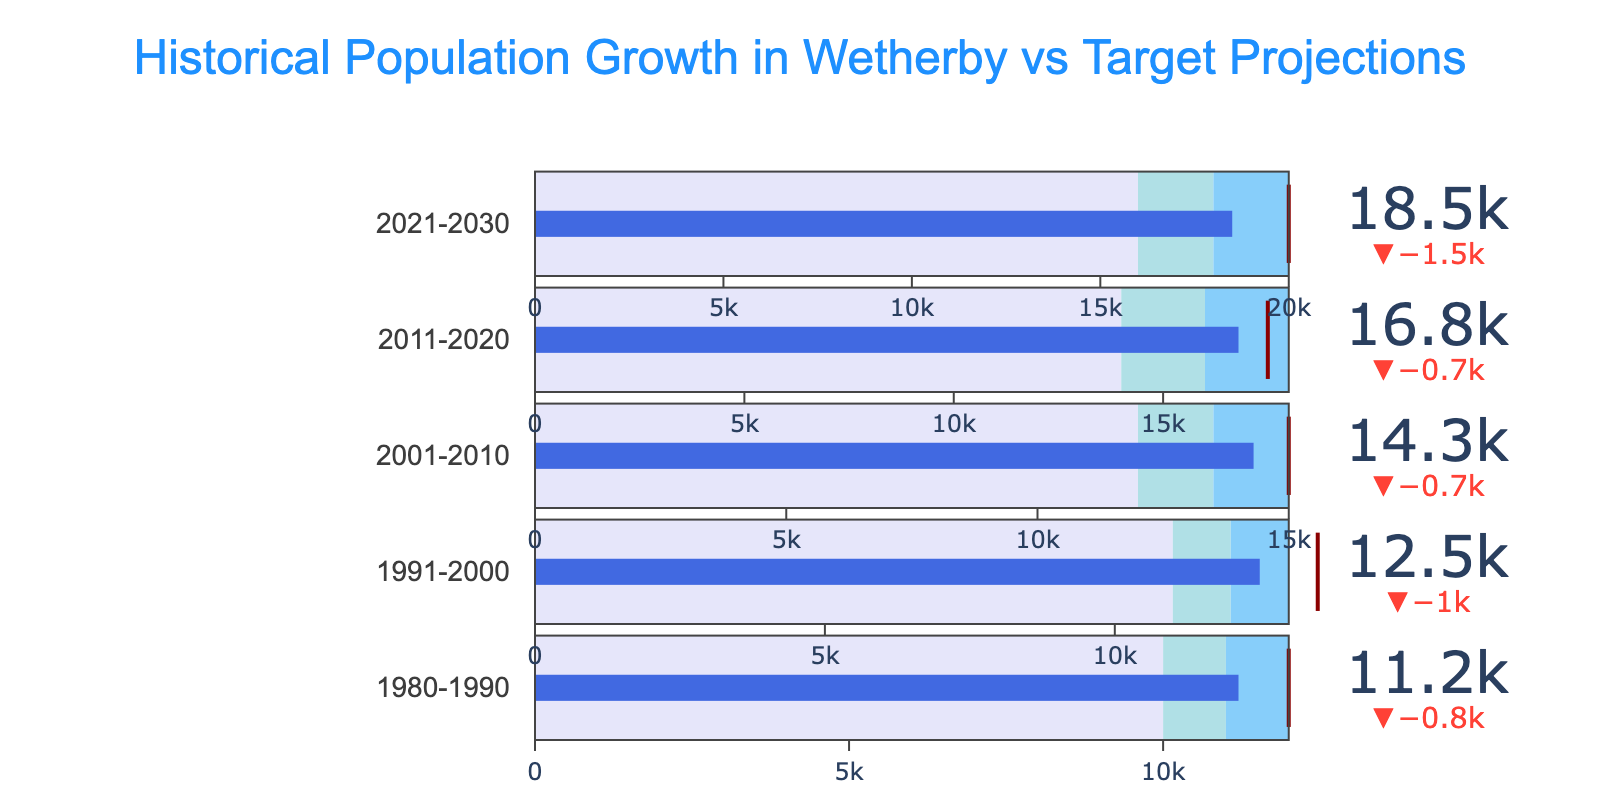What's the title of the figure? The title is prominently displayed at the top of the figure in a larger font size.
Answer: Historical Population Growth in Wetherby vs Target Projections In which decade did Wetherby's actual population first surpass the target projection? By analyzing the bullet chart data, we observe that the actual population surpassed the target in the decade 2011-2020 where the actual value (16800) exceeds the target (17500).
Answer: 2011-2020 How many decades are represented in the figure? The figure has sections corresponding to each decade, counting them we find five distinct categories.
Answer: Five What was the actual population growth for Wetherby in 2001-2010? Referring to the section labeled 2001-2010 in the figure, the actual population value is given explicitly.
Answer: 14300 How does the actual population in 2021-2030 compare to the target projection? Comparing the actual population (18500) with the target projection (20000) for this period, it is observed that the actual population is slightly below the target.
Answer: Below target During which decade did Wetherby's population have the smallest difference from its target? To find this, subtract the actual population from the target for each decade and identify the one with the smallest difference. The smallest difference is in the decade 2011-2020 (700).
Answer: 2011-2020 What is the color representing the first range in each bullet chart? Observing the bullet charts, the color of the first range is consistently the lighter shade.
Answer: Light purple (lavender) What is the difference between the actual and target populations for the decade 1980-1990? Subtract the actual population (11200) from the target (12000) for this decade to find the difference.
Answer: 800 How many color ranges are shown in each bullet chart? Each bullet chart section has three distinct color ranges visually representing different population thresholds.
Answer: Three Which decade shows the greatest growth in Wetherby’s actual population compared to the previous decade? Calculate the population growth for each decade compared to the previous one and find the decade with the largest increase. The greatest increase is between 2011-2020 (16800) and 2001-2010 (14300) which is 2500.
Answer: 2011-2020 